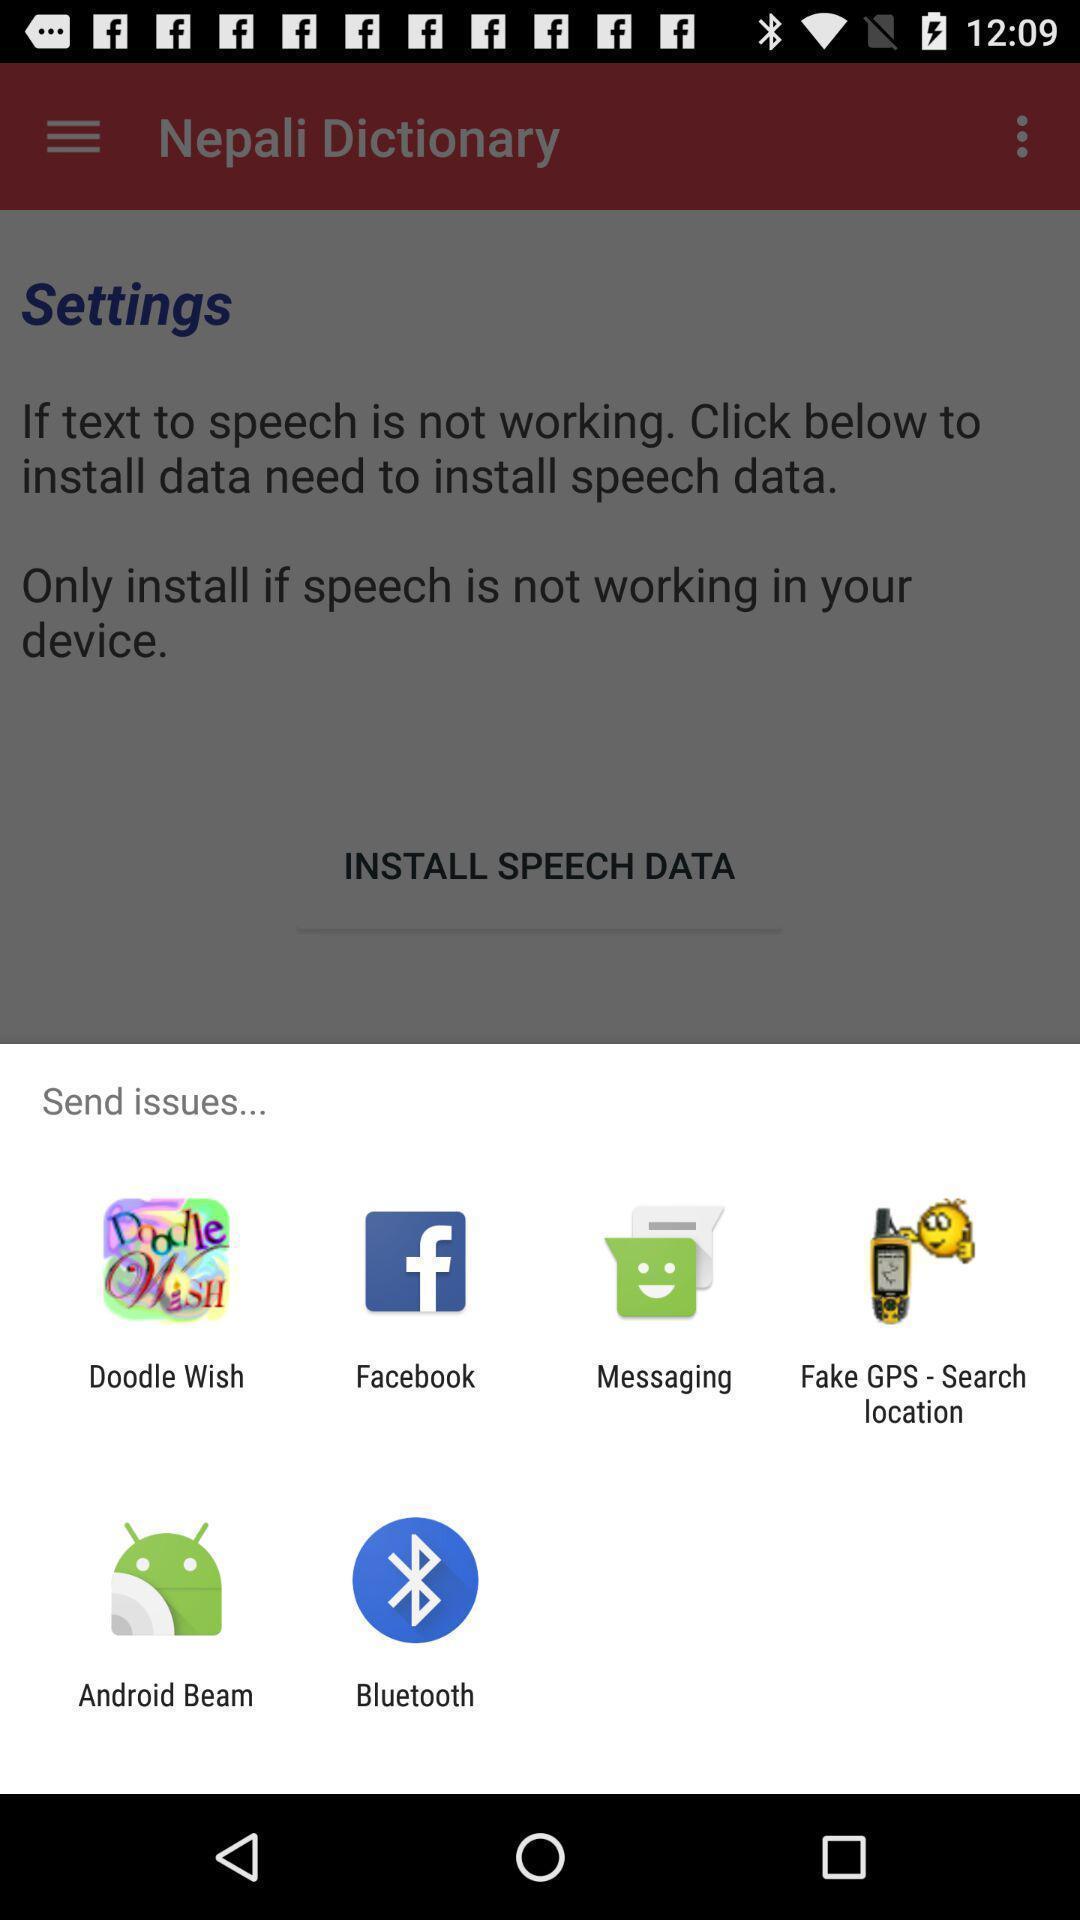Describe the key features of this screenshot. Pop-up widget showing different data sharing apps. 